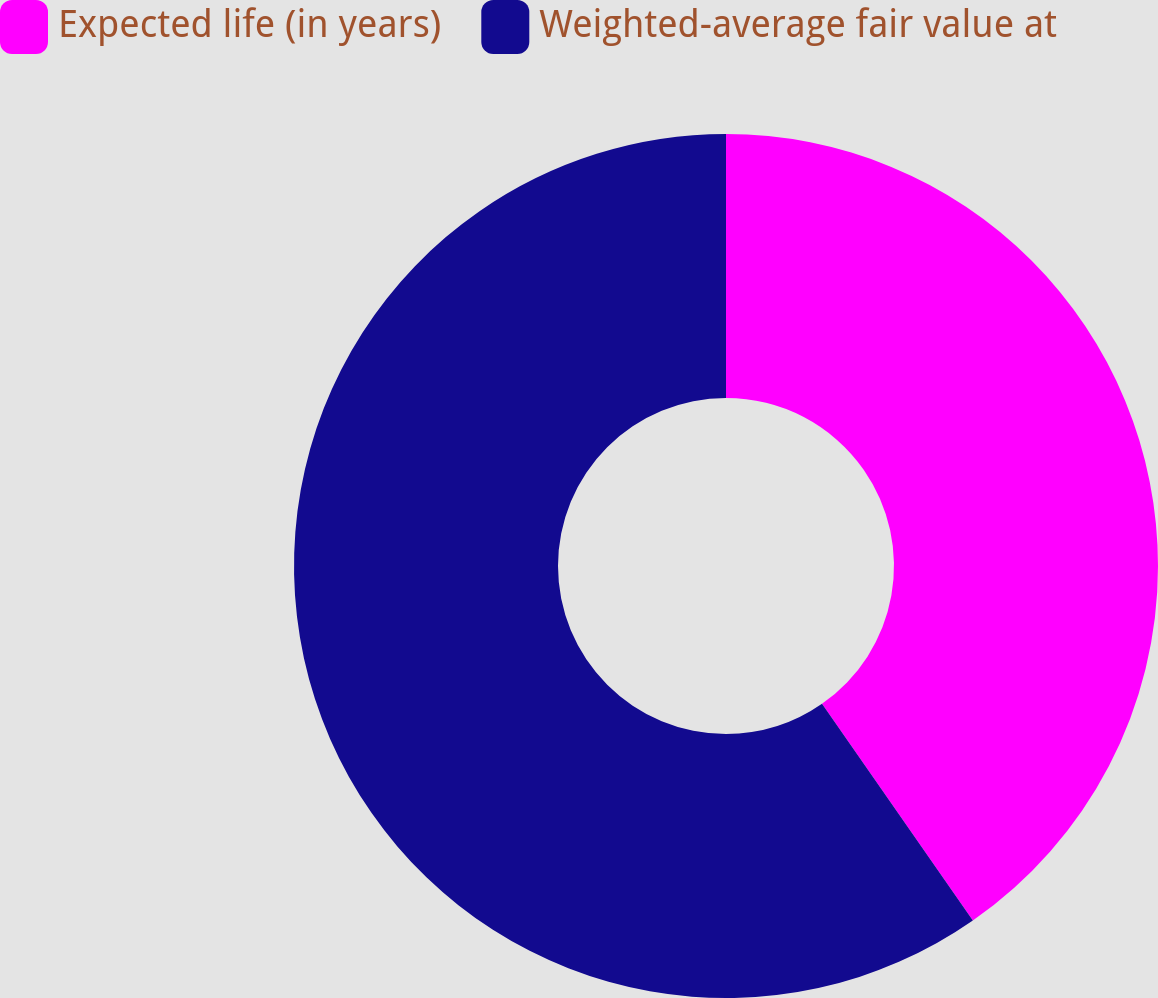Convert chart. <chart><loc_0><loc_0><loc_500><loc_500><pie_chart><fcel>Expected life (in years)<fcel>Weighted-average fair value at<nl><fcel>40.32%<fcel>59.68%<nl></chart> 